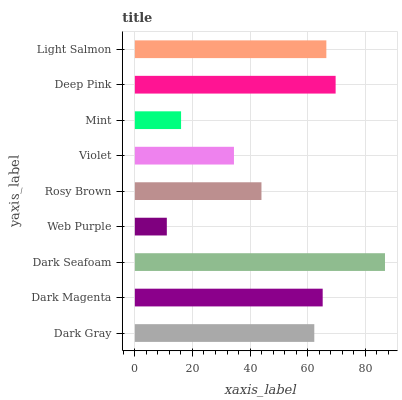Is Web Purple the minimum?
Answer yes or no. Yes. Is Dark Seafoam the maximum?
Answer yes or no. Yes. Is Dark Magenta the minimum?
Answer yes or no. No. Is Dark Magenta the maximum?
Answer yes or no. No. Is Dark Magenta greater than Dark Gray?
Answer yes or no. Yes. Is Dark Gray less than Dark Magenta?
Answer yes or no. Yes. Is Dark Gray greater than Dark Magenta?
Answer yes or no. No. Is Dark Magenta less than Dark Gray?
Answer yes or no. No. Is Dark Gray the high median?
Answer yes or no. Yes. Is Dark Gray the low median?
Answer yes or no. Yes. Is Dark Magenta the high median?
Answer yes or no. No. Is Dark Seafoam the low median?
Answer yes or no. No. 